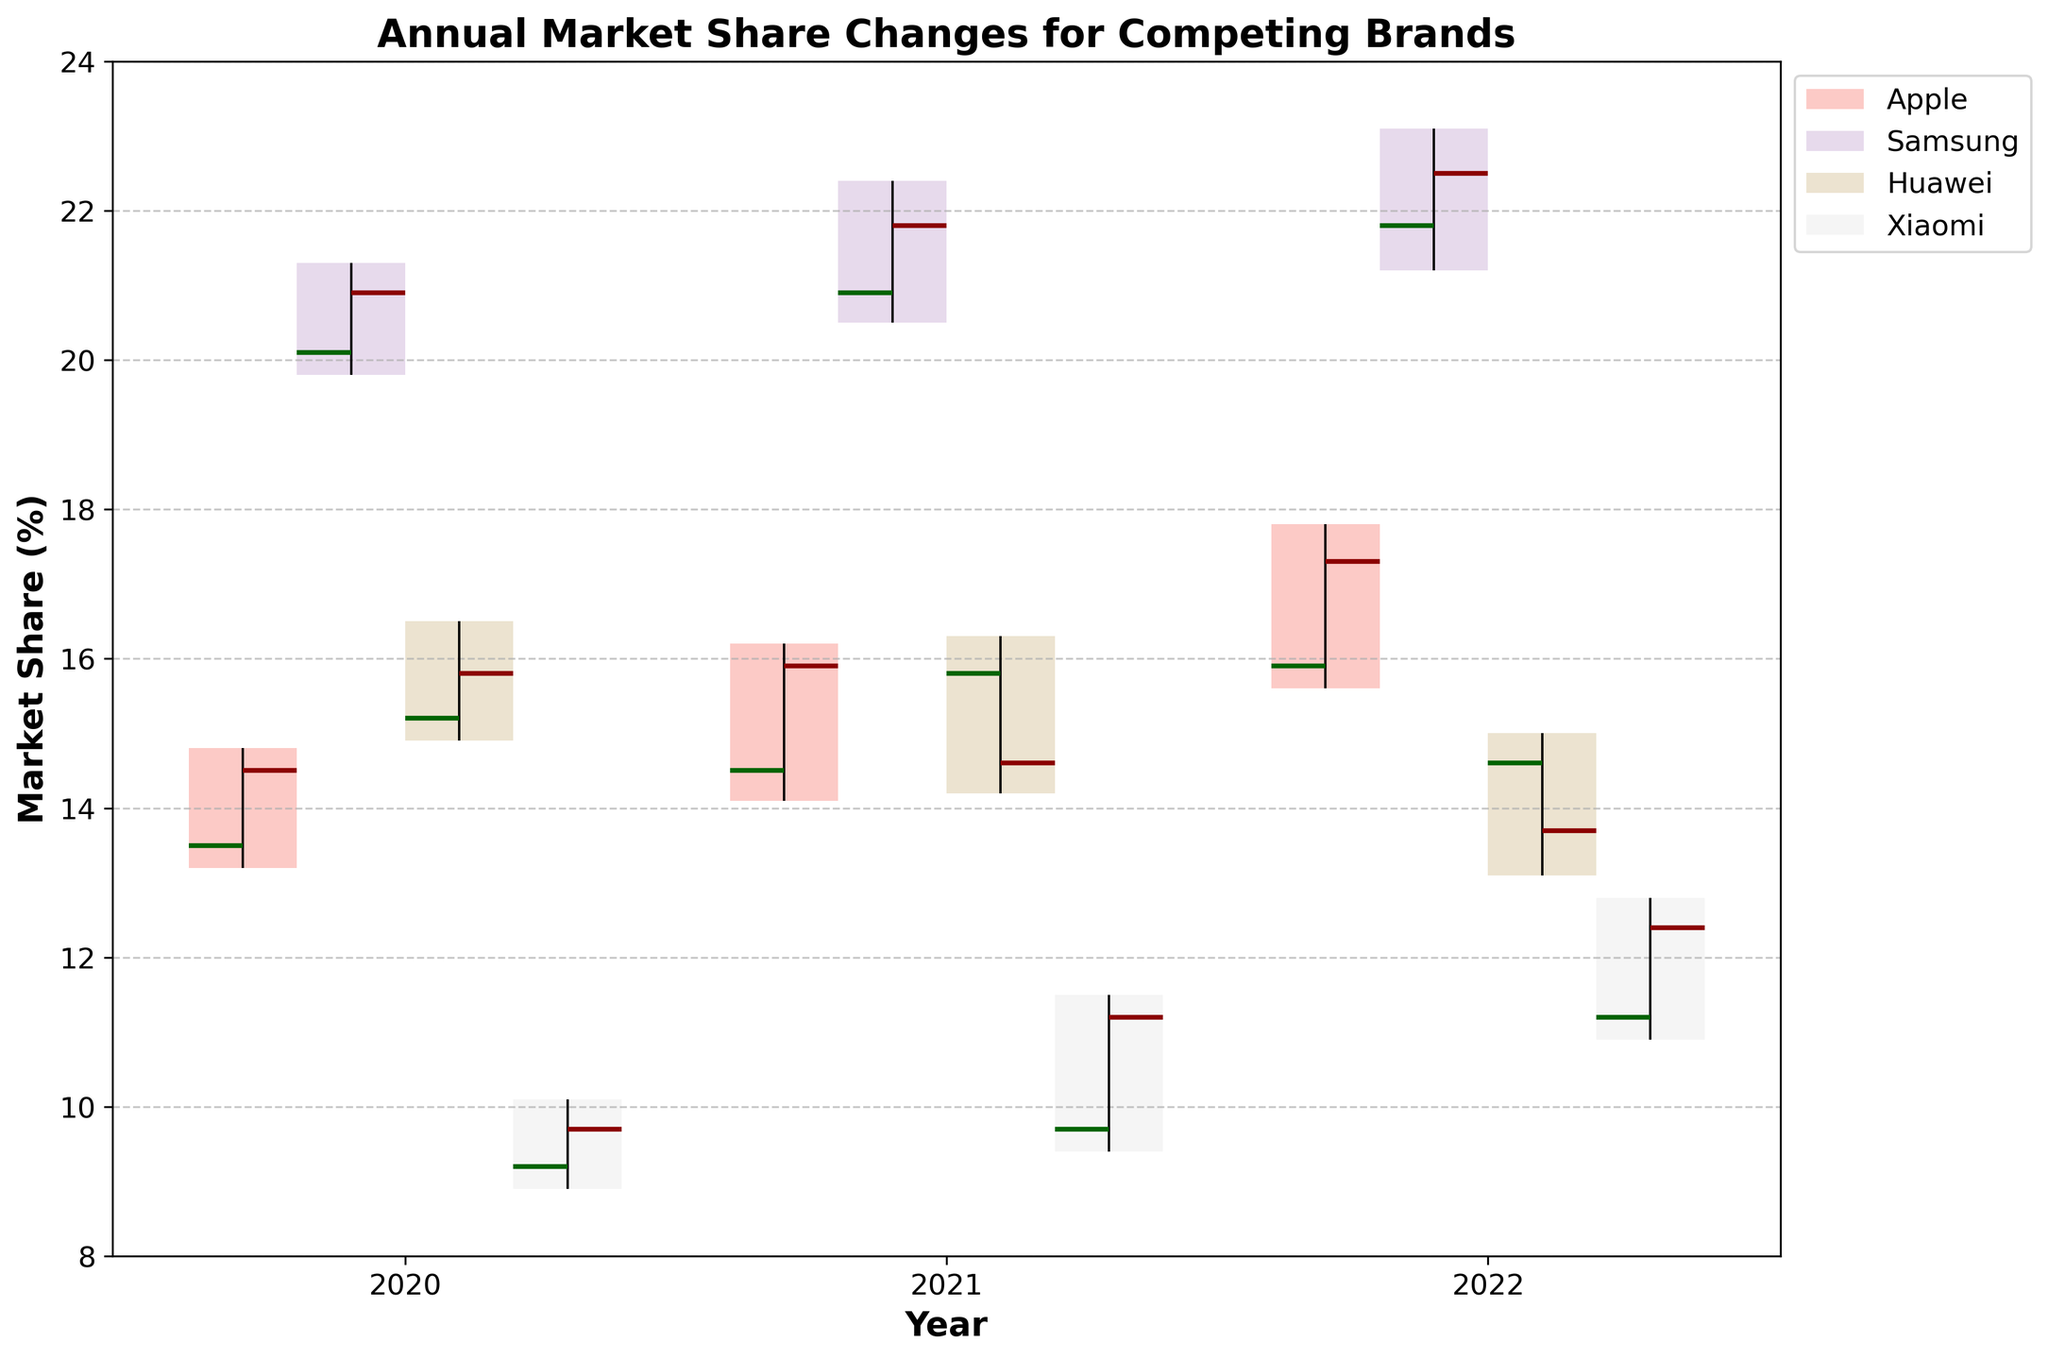What is the title of the figure? The title is usually displayed at the top of the figure and is written as a headline to provide quick context about the content being visualized. Here, it reads "Annual Market Share Changes for Competing Brands".
Answer: Annual Market Share Changes for Competing Brands Which brand has the highest market share in 2022? To find the highest market share, look at the "High" values for the year 2022. Samsung has the highest among them with a "High" value of 23.1%.
Answer: Samsung What was Apple's market share at the end of 2021? The "Close" value represents the market share at the end of the year. For Apple in 2021, the "Close" value is 15.9%.
Answer: 15.9% Which year saw the lowest market share for Huawei? To determine the lowest market share, examine the "Low" values for Huawei across the years. In 2022, Huawei's "Low" value is 13.1%, which is the lowest.
Answer: 2022 How did Xiaomi's market share change from the beginning to the end of 2020? Xiaomi's "Open" value is 9.2% and the "Close" value is 9.7% for 2020. The change is calculated as 9.7% - 9.2% = 0.5%.
Answer: Increased by 0.5% Comparing the changes, which brand gained the most market share from 2021 to 2022? Calculate the difference between "Open" and "Close" values for 2022 and 2021. Apple: 17.3-15.9=1.4, Samsung: 22.5-21.8=0.7, Huawei: 13.7-14.6=-0.9, Xiaomi: 12.4-11.2=1.2. Apple gained the most (1.4%).
Answer: Apple What was the average maximum market share (High) in 2021 for all brands? Add the "High" values for all brands in 2021 (16.2 + 22.4 + 16.3 + 11.5) and divide by the number of brands (4). Sum = 66.4, so the average is 66.4/4 = 16.6%.
Answer: 16.6% Which brand showed a decline in market share in 2021 compared to its 2020 closing value? Compare each brand's 2020 "Close" value to its 2021 "Open" value. Huawei (15.8 in 2020 to 15.8 in 2021), Apple (14.5 to 14.5), Samsung (20.9 to 20.9), Xiaomi (9.7 to 9.7). Huawei shows a decline (15.8 to 14.6 in 2021).
Answer: Huawei Which brand has the most volatile market share in 2022 based on the range between High and Low values? The volatility can be measured by the difference between "High" and "Low" values. Apple: 17.8-15.6=2.2, Samsung: 23.1-21.2=1.9, Huawei: 15-13.1=1.9, Xiaomi: 12.8-10.9=1.9. Apple has the highest volatility (2.2%).
Answer: Apple What is the range of Samsung's market share in 2020? The range is calculated as the difference between "High" and "Low" values. For Samsung in 2020, this is 21.3 - 19.8 = 1.5%.
Answer: 1.5% 